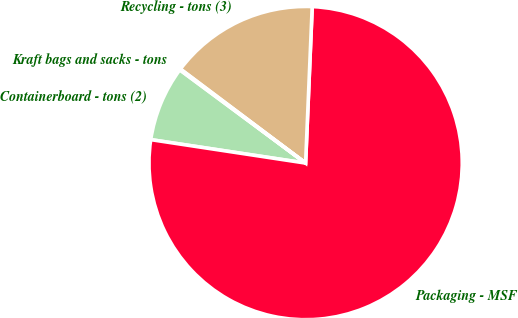Convert chart to OTSL. <chart><loc_0><loc_0><loc_500><loc_500><pie_chart><fcel>Containerboard - tons (2)<fcel>Packaging - MSF<fcel>Recycling - tons (3)<fcel>Kraft bags and sacks - tons<nl><fcel>7.76%<fcel>76.72%<fcel>15.42%<fcel>0.1%<nl></chart> 